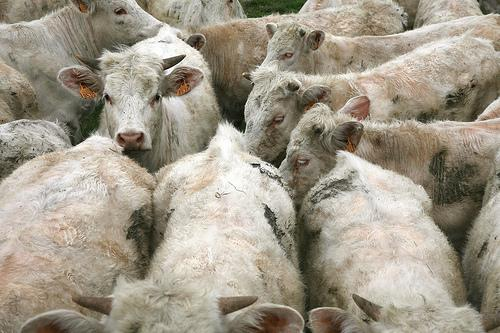Question: what color are the cows?
Choices:
A. Black.
B. White.
C. Brown.
D. Tan.
Answer with the letter. Answer: B Question: why are they so close together?
Choices:
A. Herding.
B. For warmth.
C. To feed.
D. For protection.
Answer with the letter. Answer: A Question: who took this photo?
Choices:
A. Person.
B. A dog.
C. A cat.
D. A horse.
Answer with the letter. Answer: A Question: who is looking straight?
Choices:
A. 1 cow.
B. 1 pig.
C. 1 horse.
D. 2 pigs.
Answer with the letter. Answer: A Question: where is this scene?
Choices:
A. At a cattle ranch.
B. At a cow farm.
C. At a diary farm.
D. At an organic farm.
Answer with the letter. Answer: B 